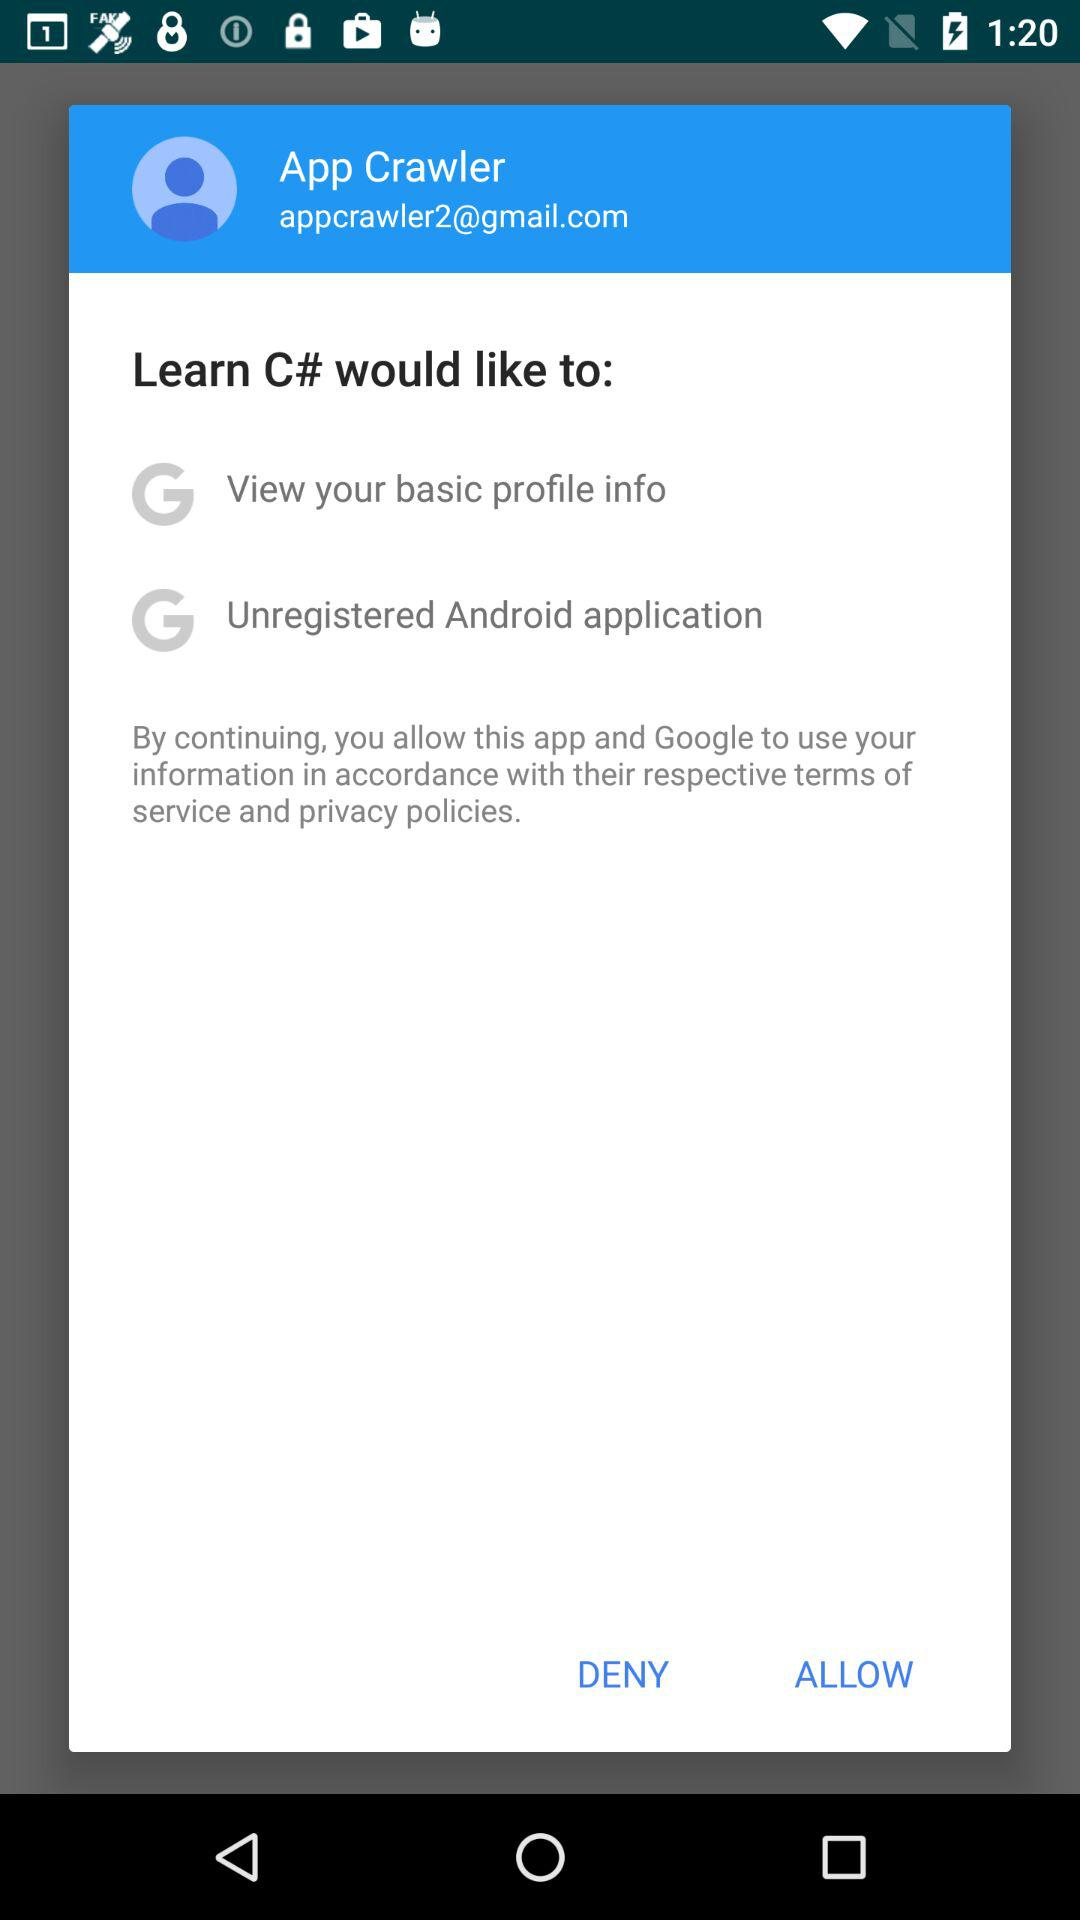What is the email address? The email address is appcrawler2@gmail.com. 